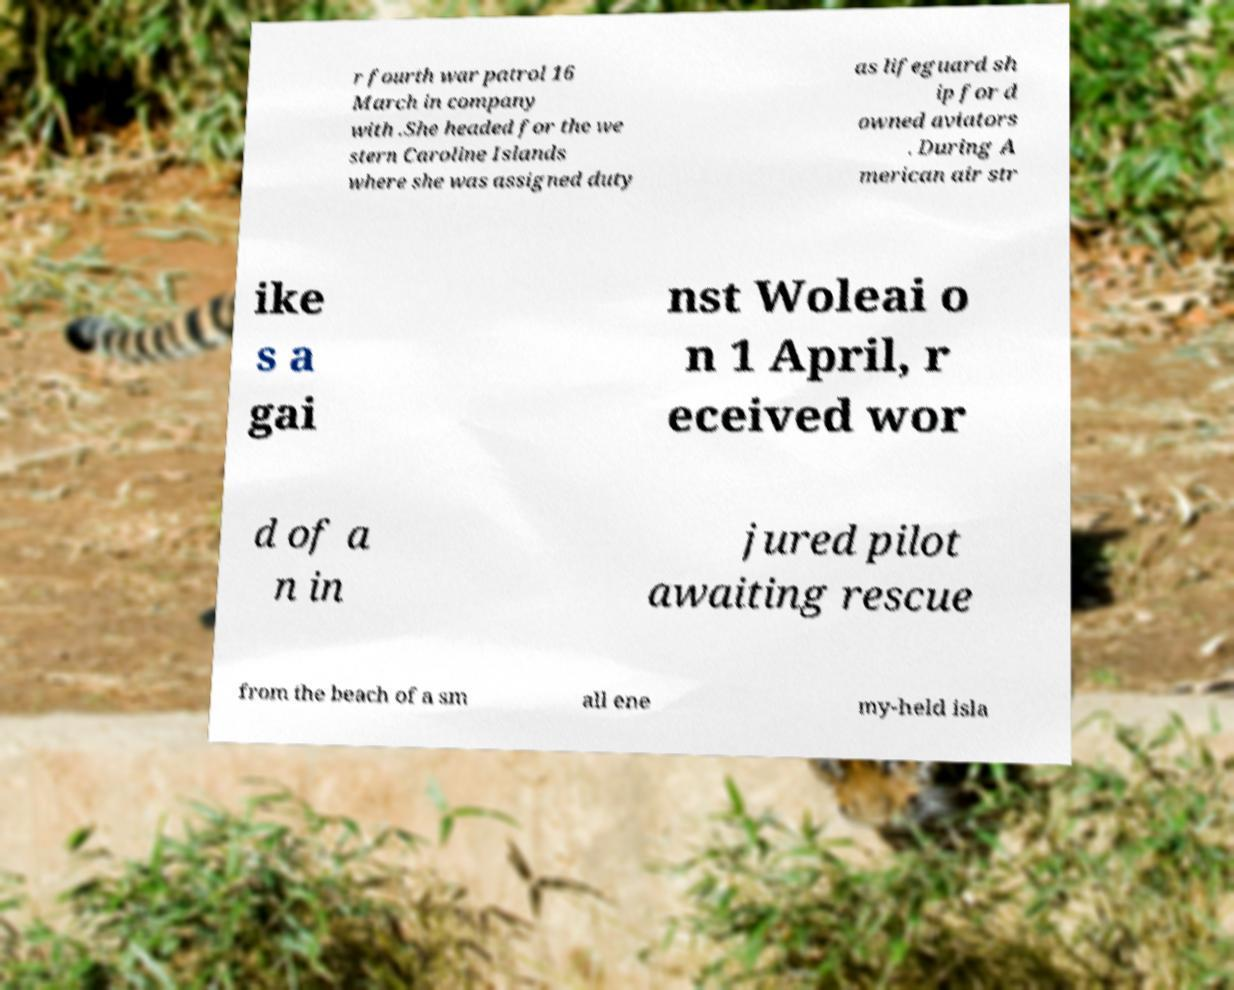Please read and relay the text visible in this image. What does it say? r fourth war patrol 16 March in company with .She headed for the we stern Caroline Islands where she was assigned duty as lifeguard sh ip for d owned aviators . During A merican air str ike s a gai nst Woleai o n 1 April, r eceived wor d of a n in jured pilot awaiting rescue from the beach of a sm all ene my-held isla 